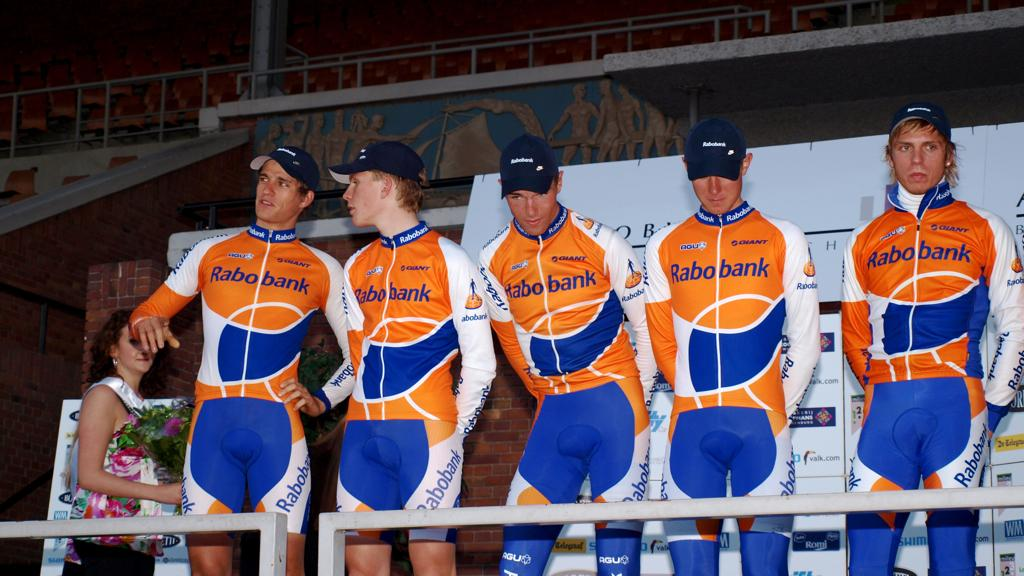What are the people in the image doing? The people in the image are standing. What is the woman holding in the image? The woman is holding a bouquet. What can be used for support or as a barrier in the image? Railings are visible in the image. What type of furniture is present in the image? Chairs are present in the image. What type of structure can be seen in the image? There is a wall in the image. What architectural feature is visible in the image? A pillar is visible in the image. What type of decoration is present in the image? Banners are present in the image. What type of gate can be seen in the image? There is no gate present in the image. What type of queen is depicted in the image? There is no queen depicted in the image. What riddle is being solved by the people in the image? There is no riddle being solved by the people in the image. 